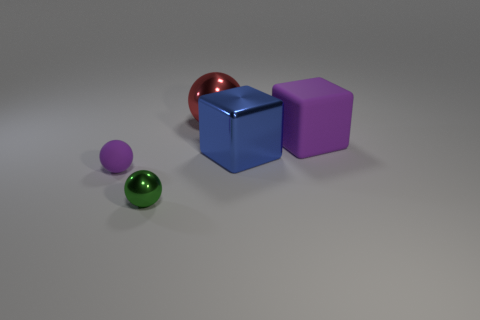Subtract all tiny metal balls. How many balls are left? 2 Add 2 metallic objects. How many objects exist? 7 Subtract all purple spheres. How many spheres are left? 2 Subtract all balls. How many objects are left? 2 Add 5 metallic blocks. How many metallic blocks exist? 6 Subtract 0 gray cubes. How many objects are left? 5 Subtract all red spheres. Subtract all gray cylinders. How many spheres are left? 2 Subtract all purple rubber blocks. Subtract all red metallic things. How many objects are left? 3 Add 2 tiny green shiny things. How many tiny green shiny things are left? 3 